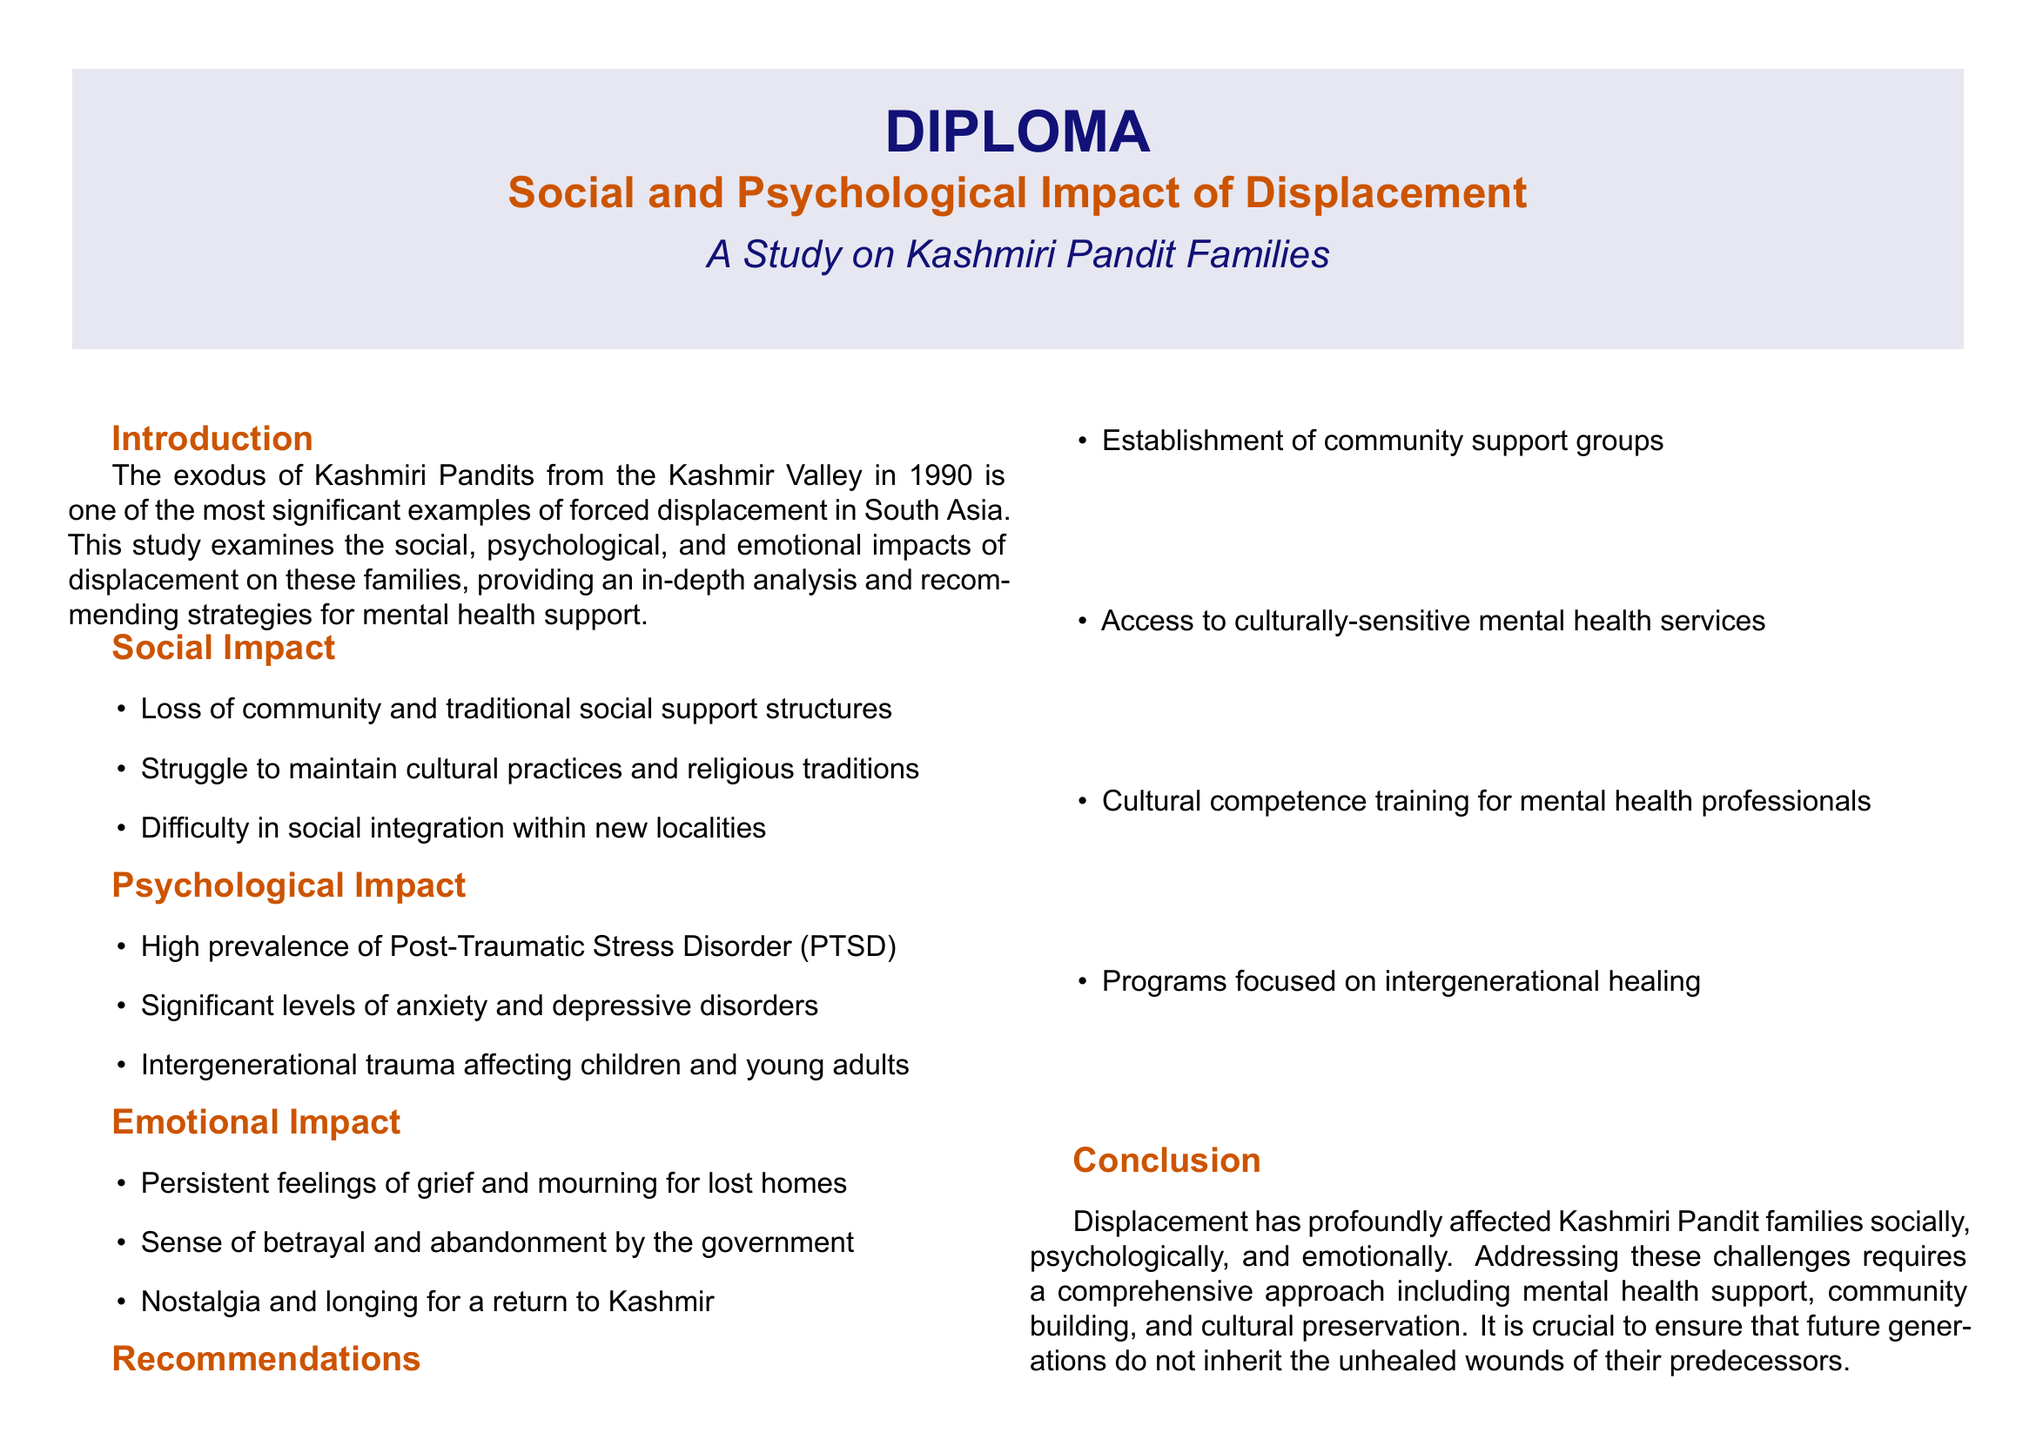What is the title of the diploma? The title of the diploma is specified in the document's header section.
Answer: Social and Psychological Impact of Displacement What year did the exodus of Kashmiri Pandits occur? The document indicates the year of the exodus in the introduction section.
Answer: 1990 Which psychological disorder is highlighted as prevalent among displaced families? The document lists specific psychological impacts in its analysis of psychological effects.
Answer: Post-Traumatic Stress Disorder What are two recommendations for mental health support? The document outlines recommendations in the specified section includes strategies for support.
Answer: Community support groups, culturally-sensitive mental health services Who is quoted regarding the challenges of starting over in Jammu? The document includes interview highlights and identifies the speaker for a particular quote.
Answer: Dr. Sunil Kachru What emotion is commonly felt by displaced individuals according to the document? The emotional impacts are discussed, showcasing feelings experienced by displaced individuals.
Answer: Grief What section discusses the loss of community? The social effects of displacement are categorized in a designated part of the document.
Answer: Social Impact What is the significance of intergenerational trauma as mentioned in the document? The psychological effects section reviews long-term impacts on successive generations.
Answer: Affected children and young adults 